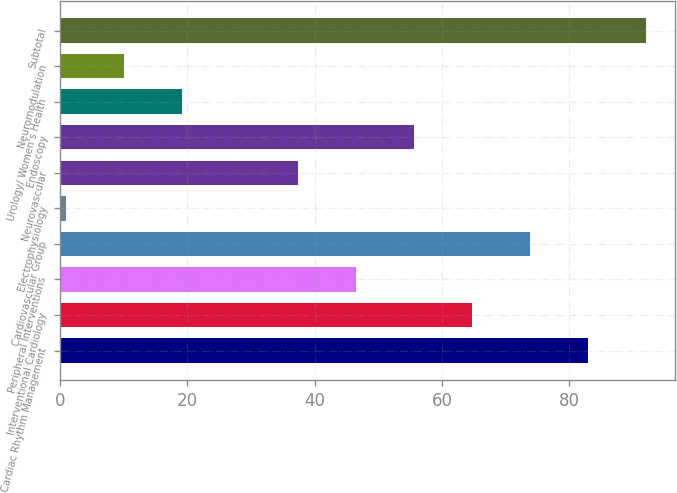Convert chart. <chart><loc_0><loc_0><loc_500><loc_500><bar_chart><fcel>Cardiac Rhythm Management<fcel>Interventional Cardiology<fcel>Peripheral Interventions<fcel>Cardiovascular Group<fcel>Electrophysiology<fcel>Neurovascular<fcel>Endoscopy<fcel>Urology/ Women's Health<fcel>Neuromodulation<fcel>Subtotal<nl><fcel>82.9<fcel>64.7<fcel>46.5<fcel>73.8<fcel>1<fcel>37.4<fcel>55.6<fcel>19.2<fcel>10.1<fcel>92<nl></chart> 